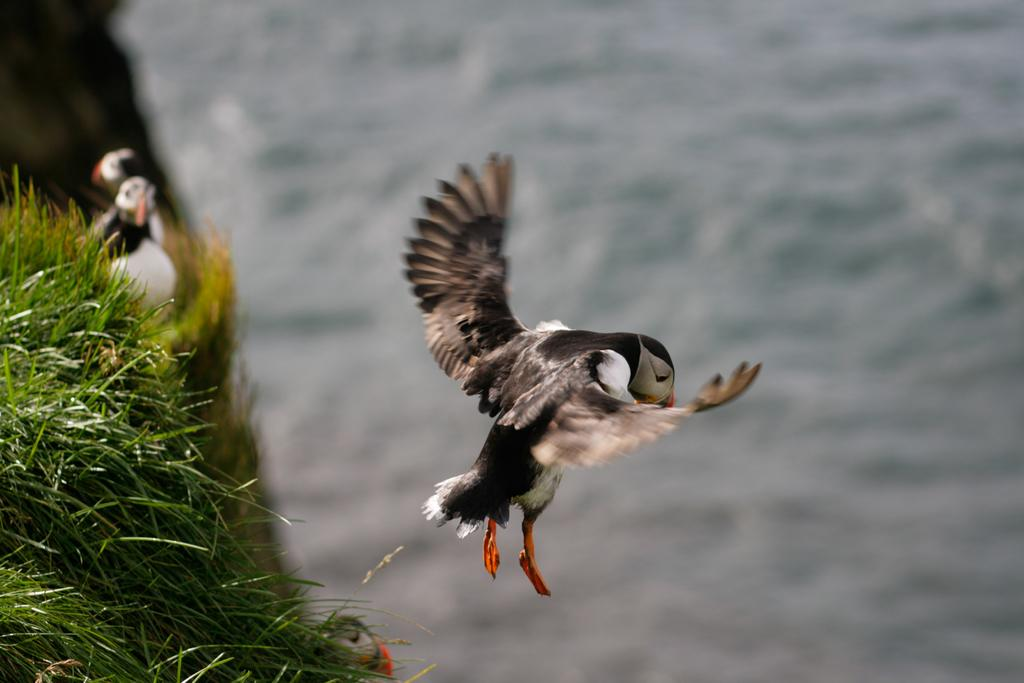What is happening in the sky in the image? There is a bird flying in the air in the image. What body of water is visible in the image? There is a river visible in the image. Where are the other birds located in the image? There are two birds on the grass on the left side of the image. What type of collar can be seen on the bird in the image? There is no collar present on the bird in the image. How many sticks are being used by the birds in the image? There are no sticks visible in the image; the birds are on the grass. 